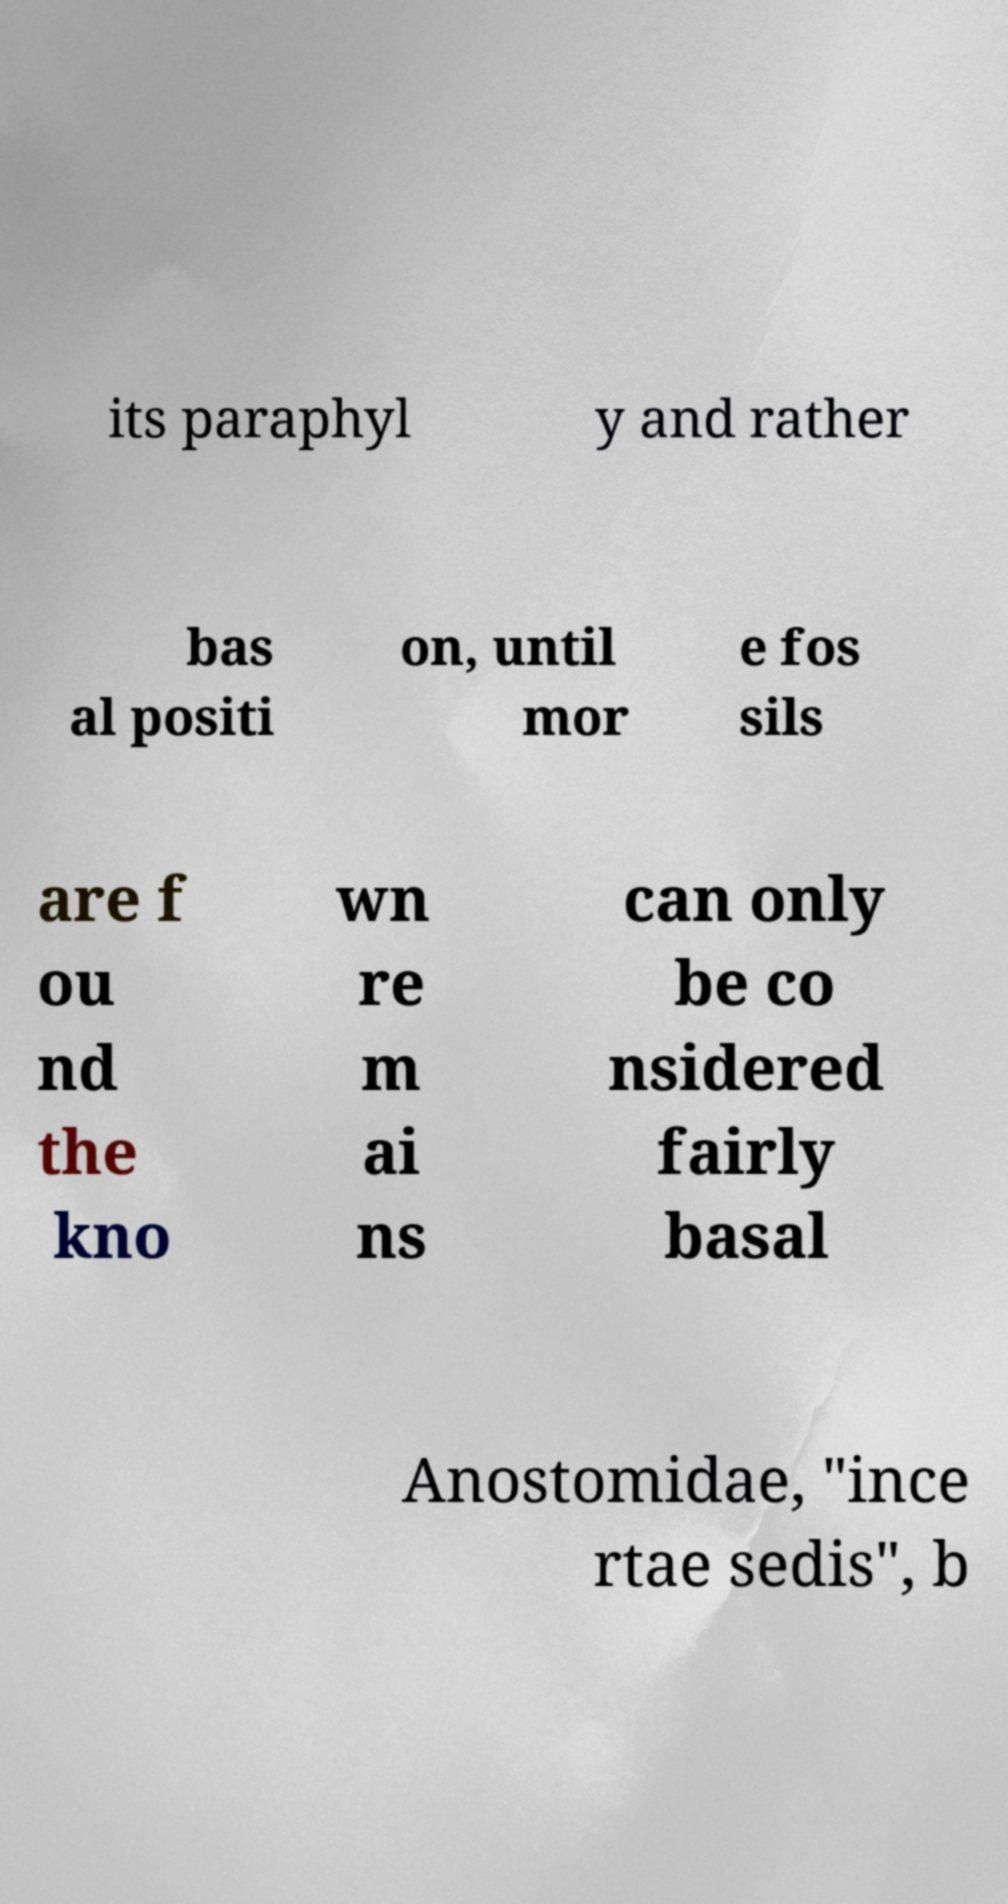I need the written content from this picture converted into text. Can you do that? its paraphyl y and rather bas al positi on, until mor e fos sils are f ou nd the kno wn re m ai ns can only be co nsidered fairly basal Anostomidae, "ince rtae sedis", b 